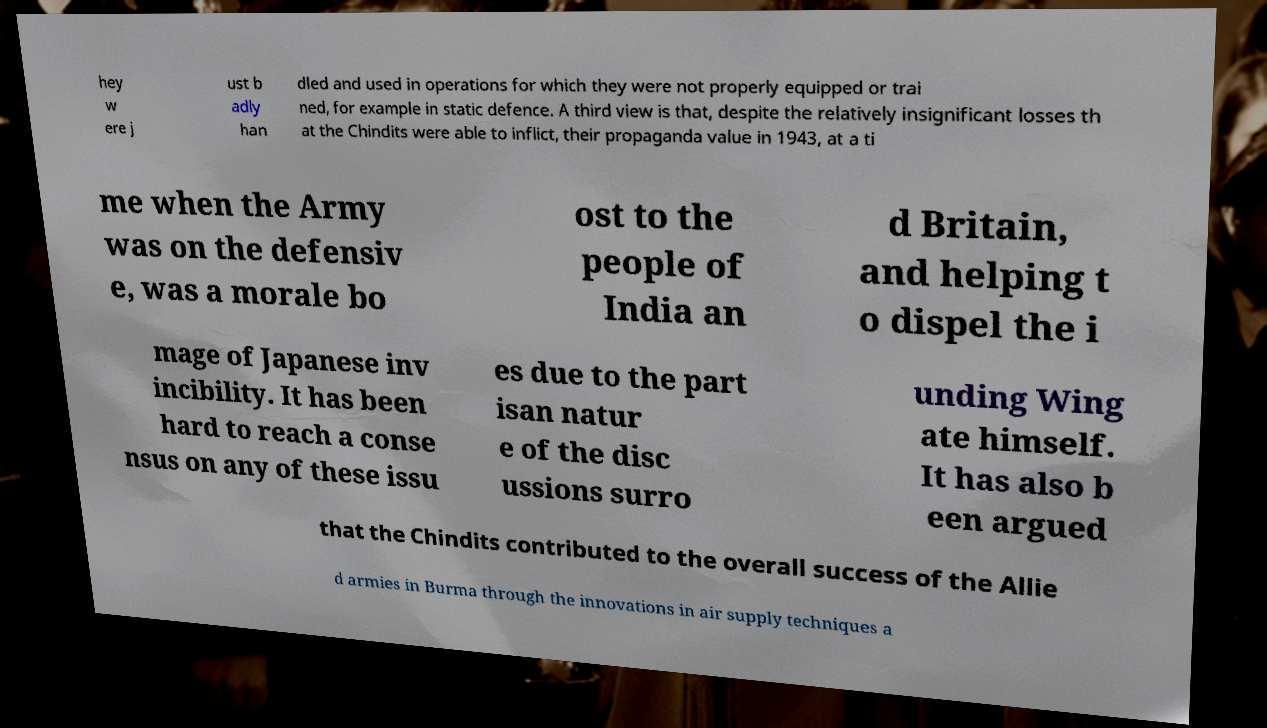For documentation purposes, I need the text within this image transcribed. Could you provide that? hey w ere j ust b adly han dled and used in operations for which they were not properly equipped or trai ned, for example in static defence. A third view is that, despite the relatively insignificant losses th at the Chindits were able to inflict, their propaganda value in 1943, at a ti me when the Army was on the defensiv e, was a morale bo ost to the people of India an d Britain, and helping t o dispel the i mage of Japanese inv incibility. It has been hard to reach a conse nsus on any of these issu es due to the part isan natur e of the disc ussions surro unding Wing ate himself. It has also b een argued that the Chindits contributed to the overall success of the Allie d armies in Burma through the innovations in air supply techniques a 